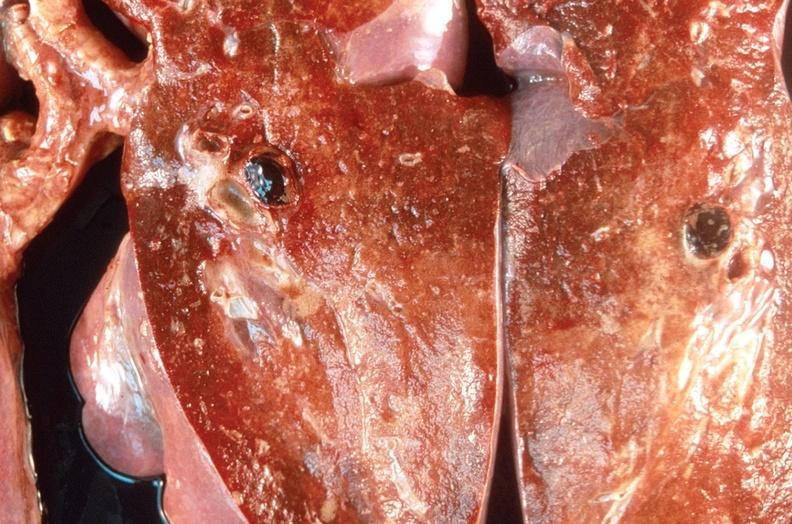what does this image show?
Answer the question using a single word or phrase. Pulmonary thromboemboli 